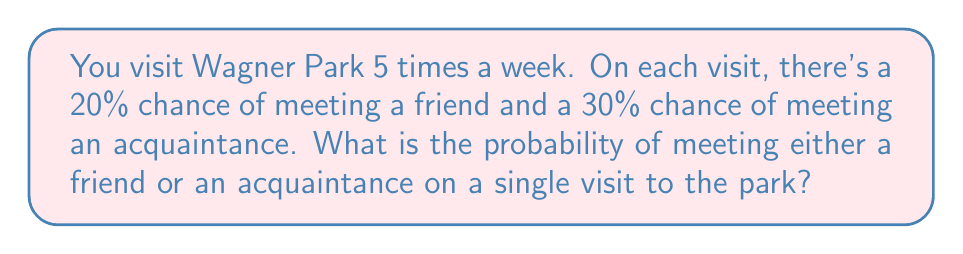Could you help me with this problem? Let's approach this step-by-step:

1) Let A be the event of meeting a friend, and B be the event of meeting an acquaintance.

2) We're given:
   P(A) = 20% = 0.2
   P(B) = 30% = 0.3

3) We need to find P(A or B), which is the probability of meeting either a friend or an acquaintance.

4) The formula for the probability of A or B is:
   P(A or B) = P(A) + P(B) - P(A and B)

5) We don't know P(A and B), but we can assume these events are independent (meeting a friend doesn't affect the chance of meeting an acquaintance and vice versa).

6) For independent events, P(A and B) = P(A) × P(B)
   P(A and B) = 0.2 × 0.3 = 0.06

7) Now we can calculate P(A or B):
   P(A or B) = P(A) + P(B) - P(A and B)
              = 0.2 + 0.3 - 0.06
              = 0.44

8) Convert to a percentage:
   0.44 × 100 = 44%

Therefore, the probability of meeting either a friend or an acquaintance on a single visit to Wagner Park is 44%.
Answer: 44% 